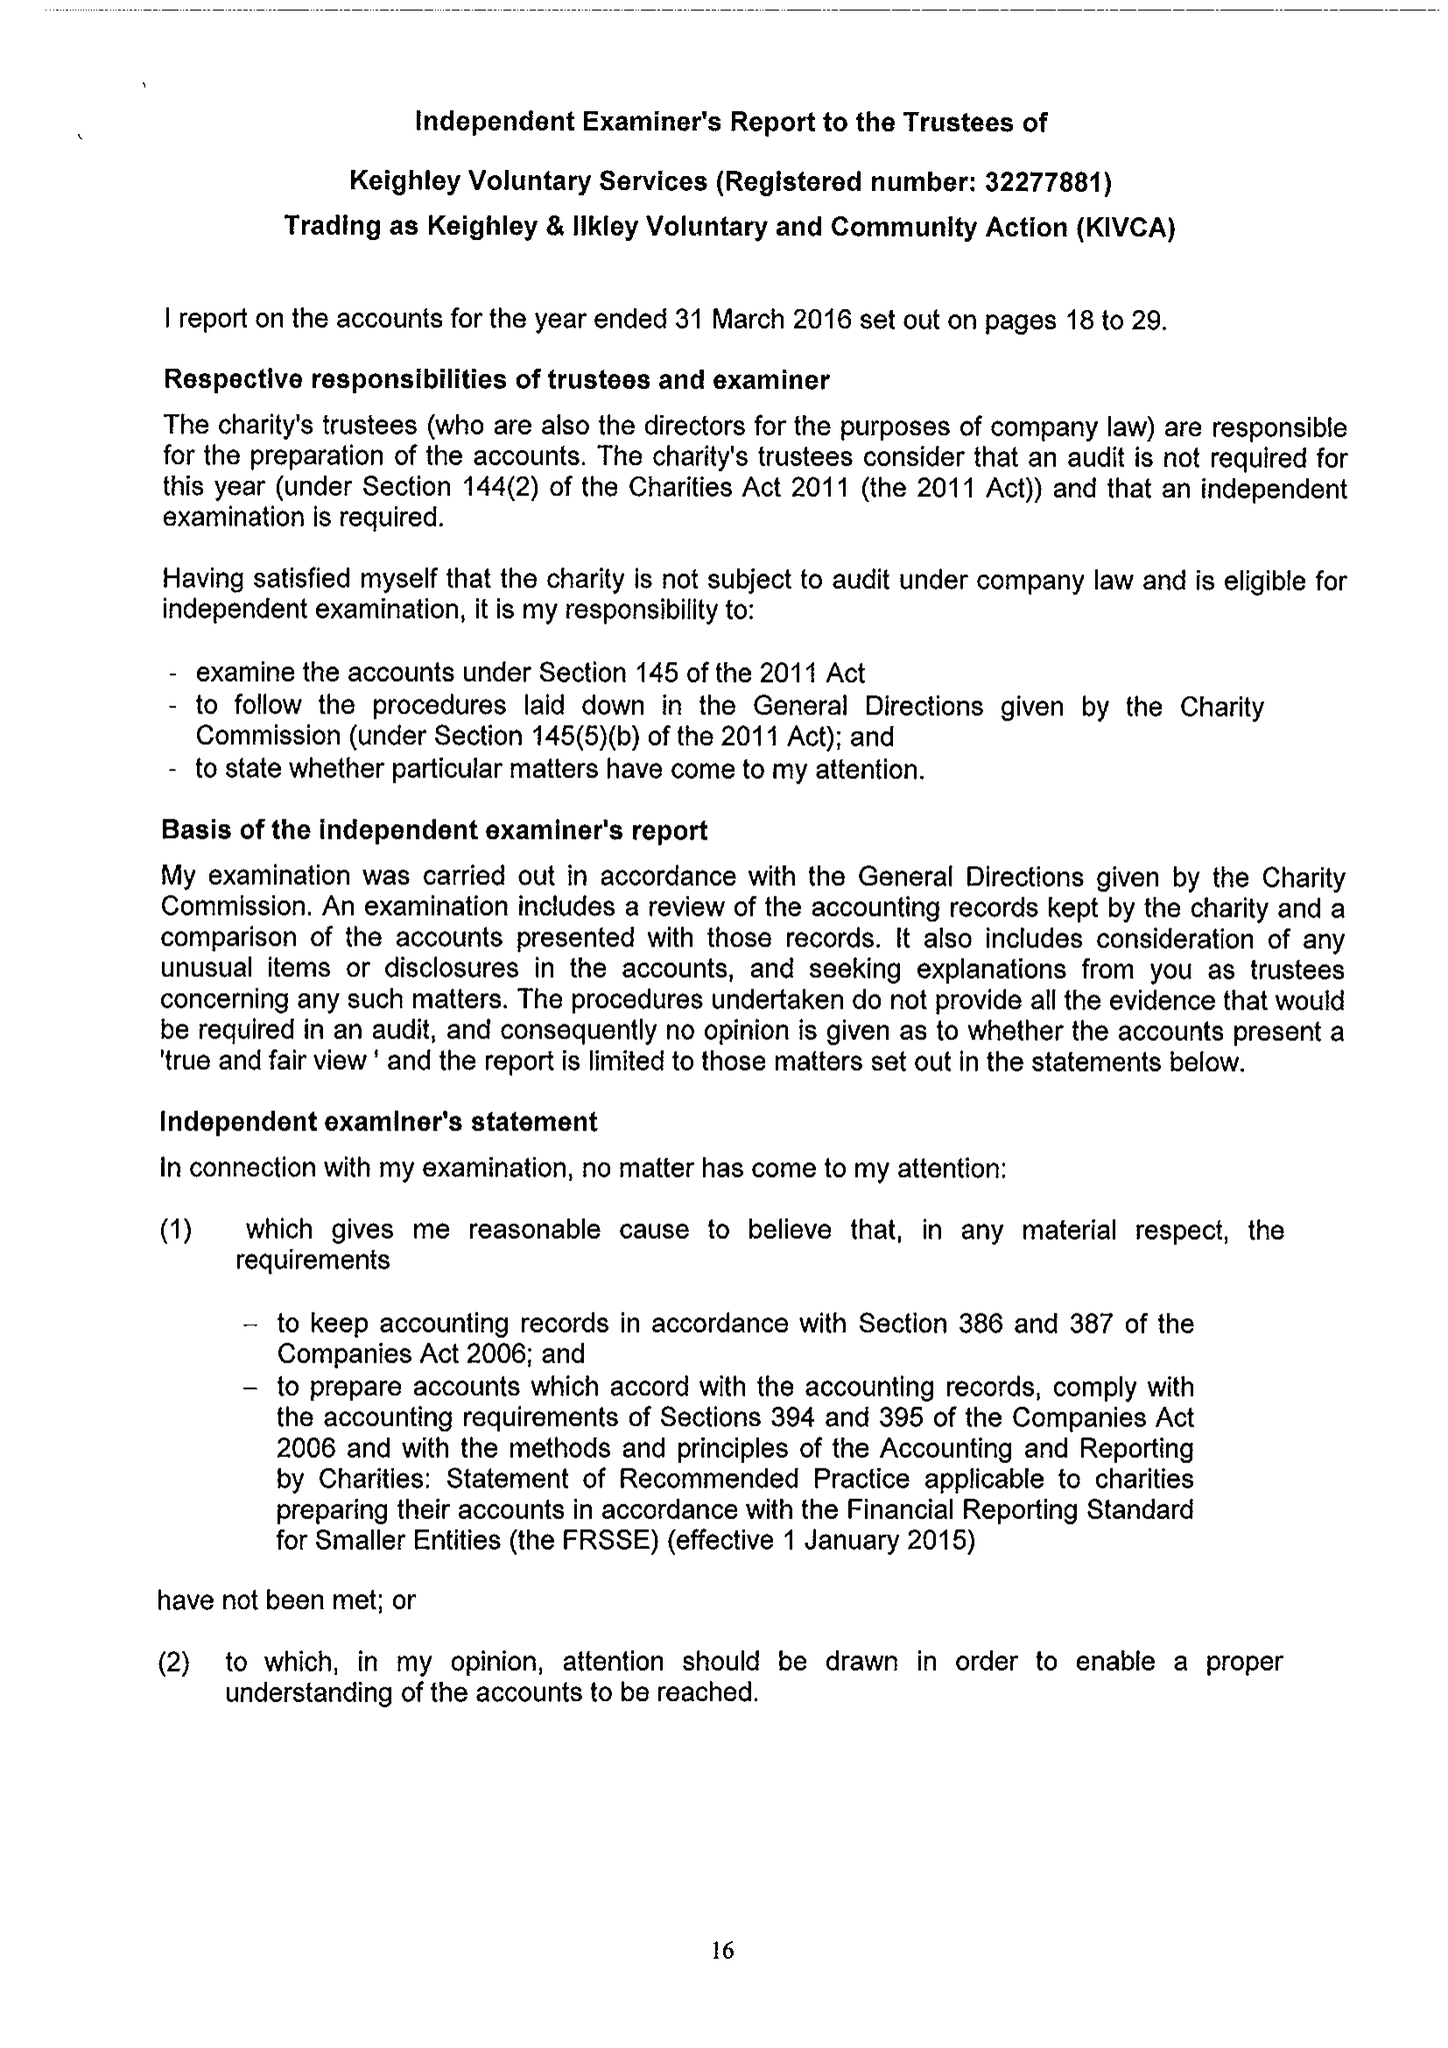What is the value for the income_annually_in_british_pounds?
Answer the question using a single word or phrase. 752470.00 